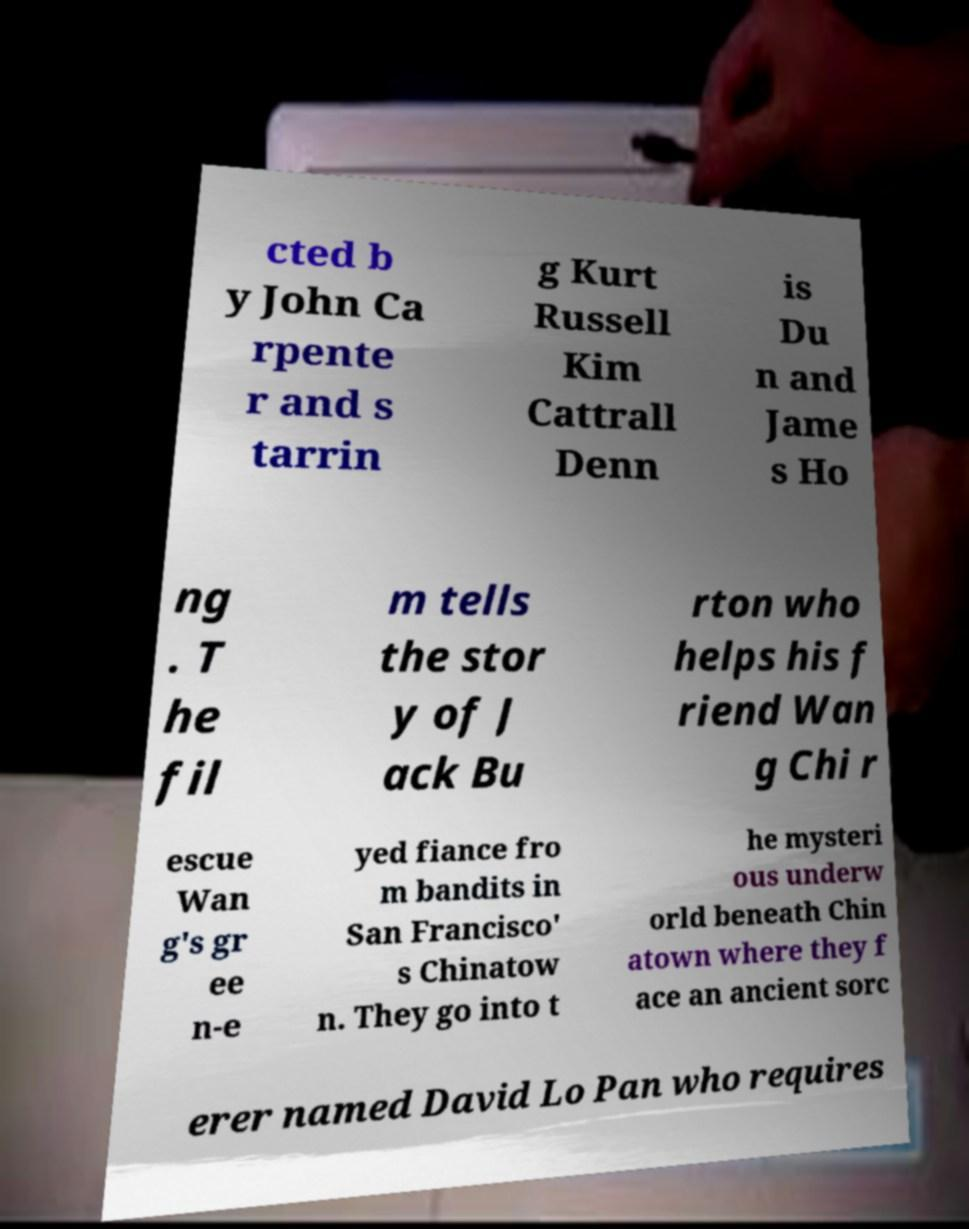Can you accurately transcribe the text from the provided image for me? cted b y John Ca rpente r and s tarrin g Kurt Russell Kim Cattrall Denn is Du n and Jame s Ho ng . T he fil m tells the stor y of J ack Bu rton who helps his f riend Wan g Chi r escue Wan g's gr ee n-e yed fiance fro m bandits in San Francisco' s Chinatow n. They go into t he mysteri ous underw orld beneath Chin atown where they f ace an ancient sorc erer named David Lo Pan who requires 